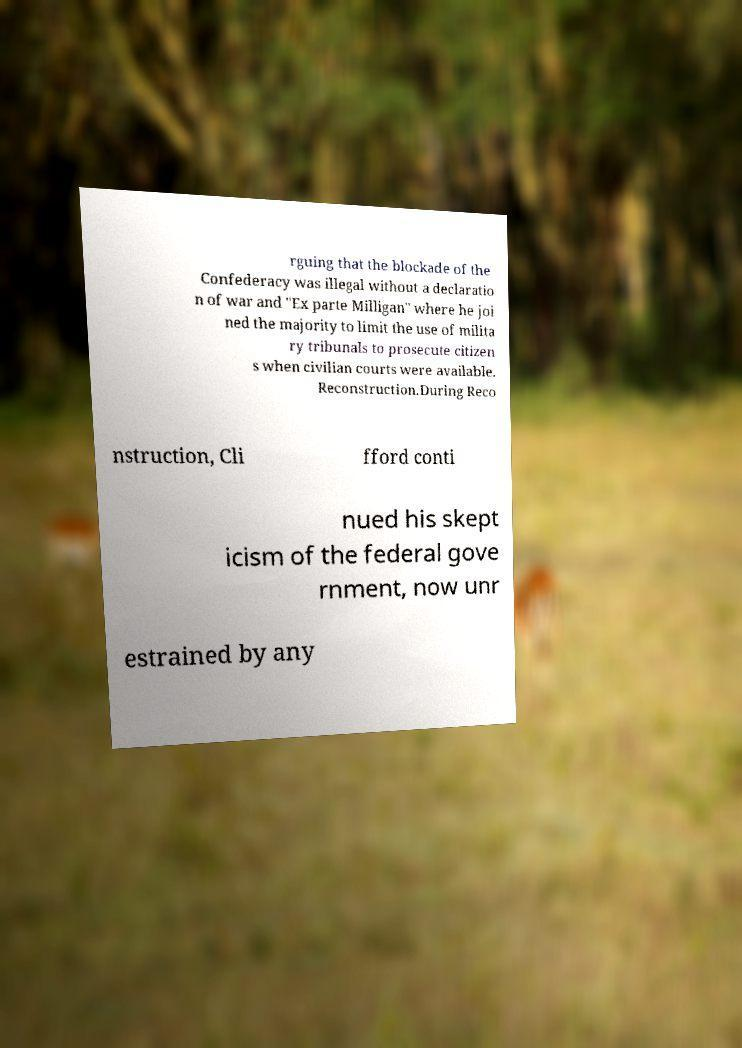Please read and relay the text visible in this image. What does it say? rguing that the blockade of the Confederacy was illegal without a declaratio n of war and "Ex parte Milligan" where he joi ned the majority to limit the use of milita ry tribunals to prosecute citizen s when civilian courts were available. Reconstruction.During Reco nstruction, Cli fford conti nued his skept icism of the federal gove rnment, now unr estrained by any 